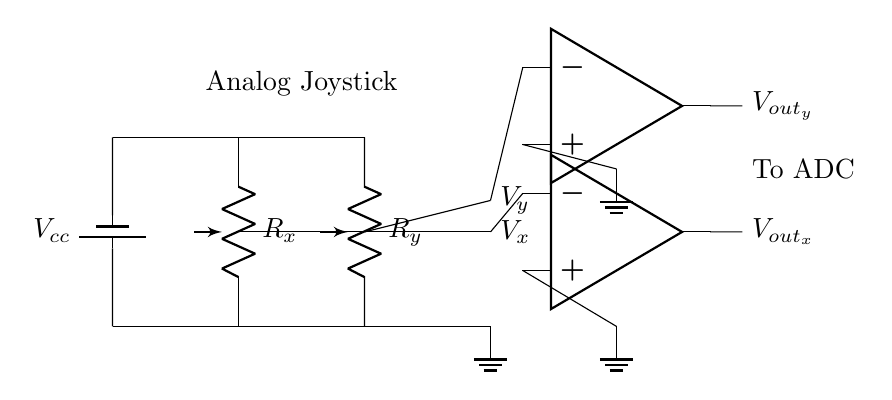What are the main components in this circuit? The main components visible in this circuit diagram are two potentiometers, a battery, two operational amplifiers, and connections to voltage outputs.
Answer: Potentiometers, battery, operational amplifiers What do R_x and R_y represent in this context? R_x and R_y are the variable resistances represented by the potentiometers that convert the joystick's mechanical movement into variable voltage signals.
Answer: Variable resistances What is the purpose of the operational amplifiers in this circuit? The operational amplifiers are used to amplify the voltage signals generated by the potentiometers, enabling them to drive other components, such as an Analog-to-Digital Converter (ADC).
Answer: Signal amplification What is the voltage supplied by the battery, labeled as V_cc? The battery provides a positive voltage supply labeled as V_cc; however, the exact value is not specified in the diagram, but typically it can be 5V for such circuits.
Answer: V_cc How are V_x and V_y related to the joystick's position? V_x is the voltage output corresponding to horizontal movement (x-axis) of the joystick, while V_y corresponds to vertical movement (y-axis). The positions of the joystick affect these voltages proportionally.
Answer: Voltage outputs for joystick positions What connections go to the output of the op-amps? The output of the operational amplifiers connects to the right side of the circuit, indicating the output voltages V_out_x and V_out_y that will drive further components or ADCs.
Answer: Outputs V_out_x and V_out_y 